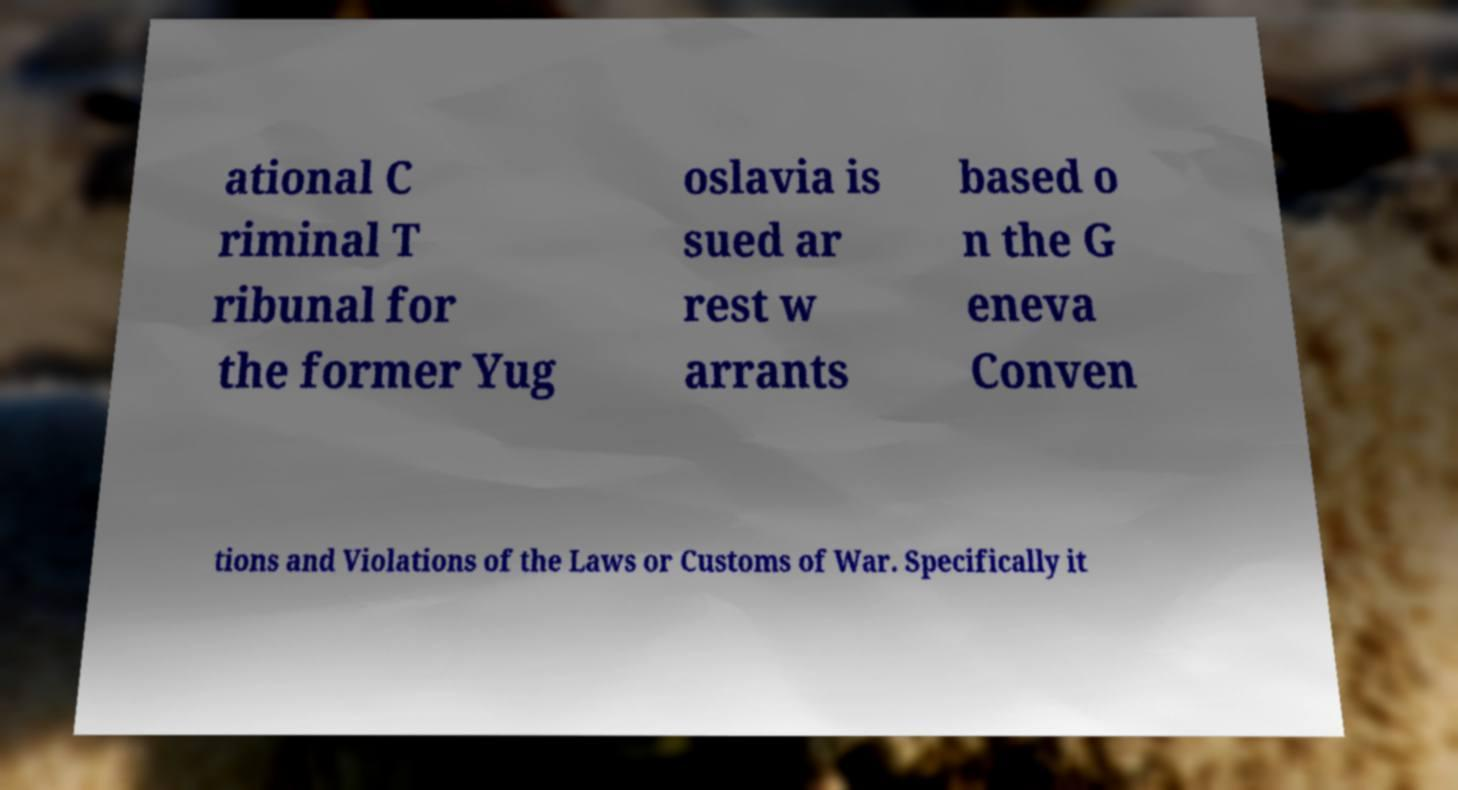For documentation purposes, I need the text within this image transcribed. Could you provide that? ational C riminal T ribunal for the former Yug oslavia is sued ar rest w arrants based o n the G eneva Conven tions and Violations of the Laws or Customs of War. Specifically it 